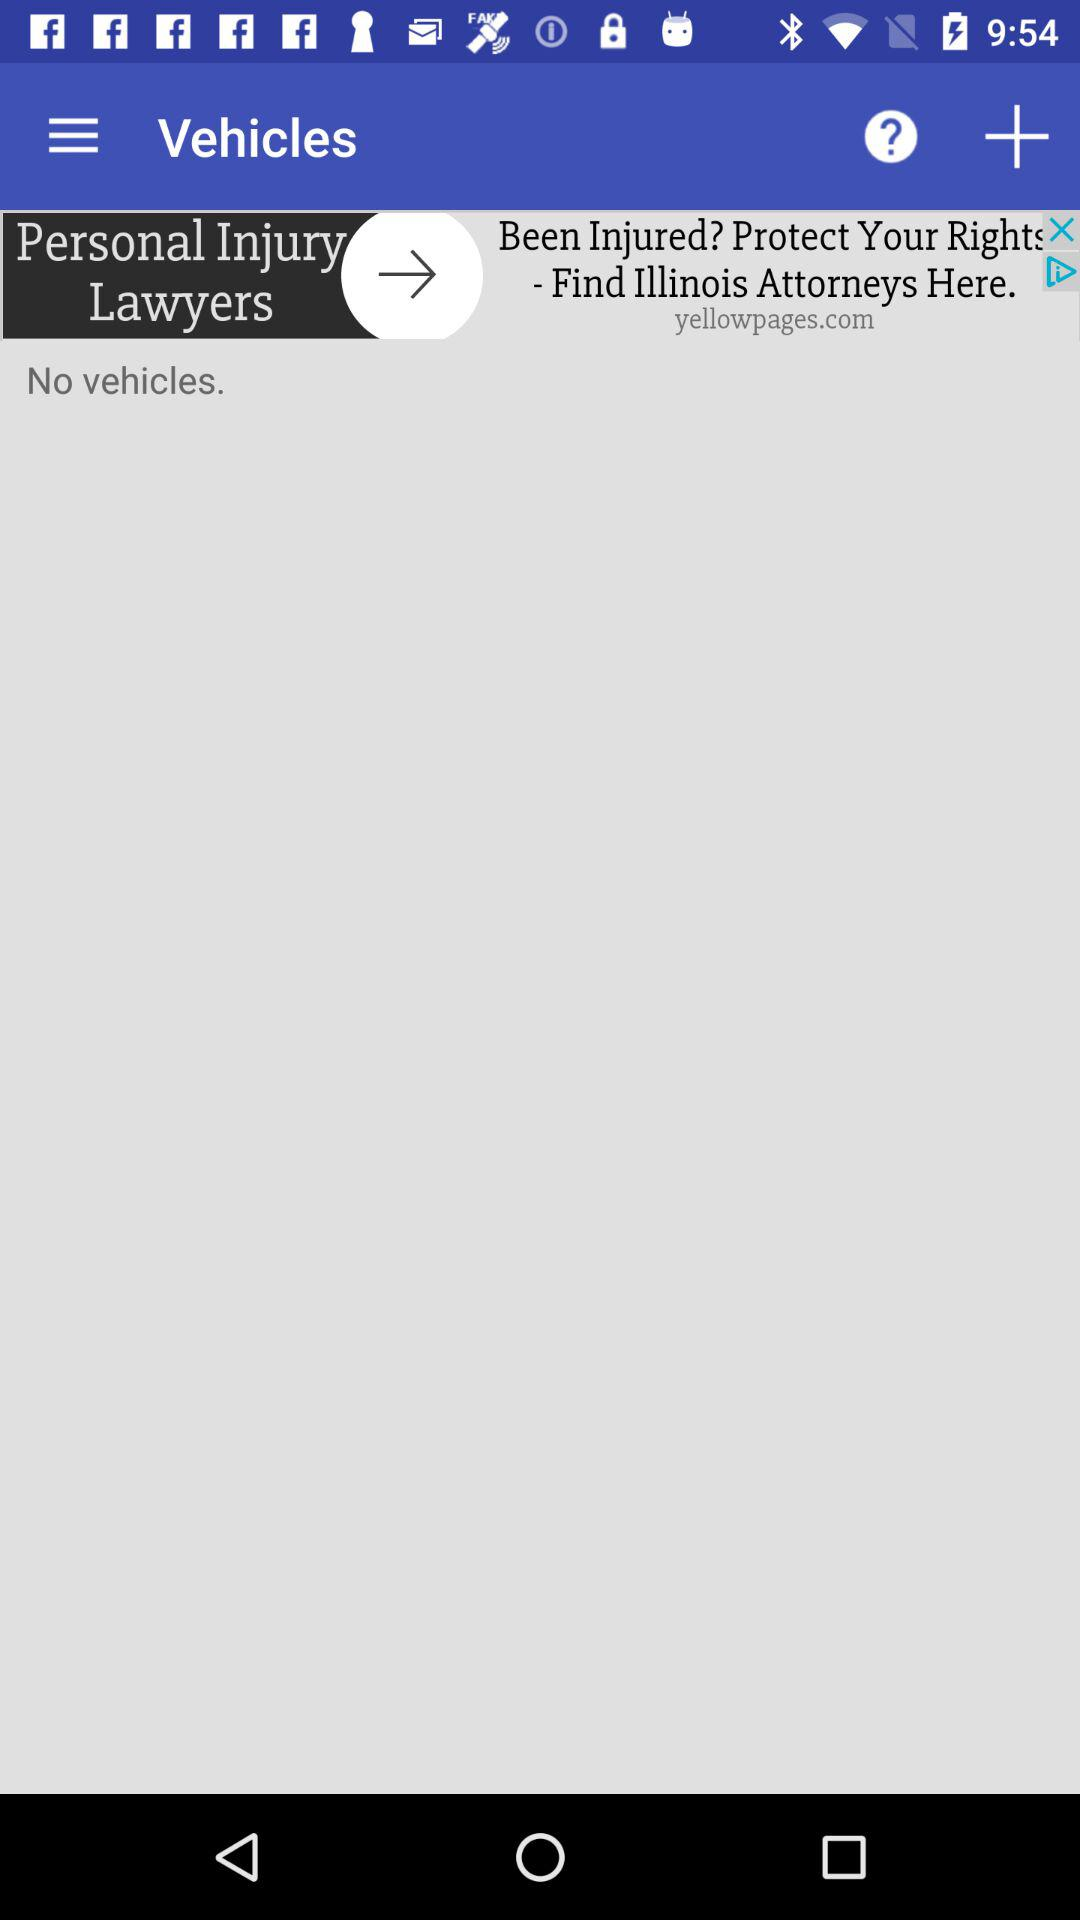How many vehicles are there? There are no vehicles. 